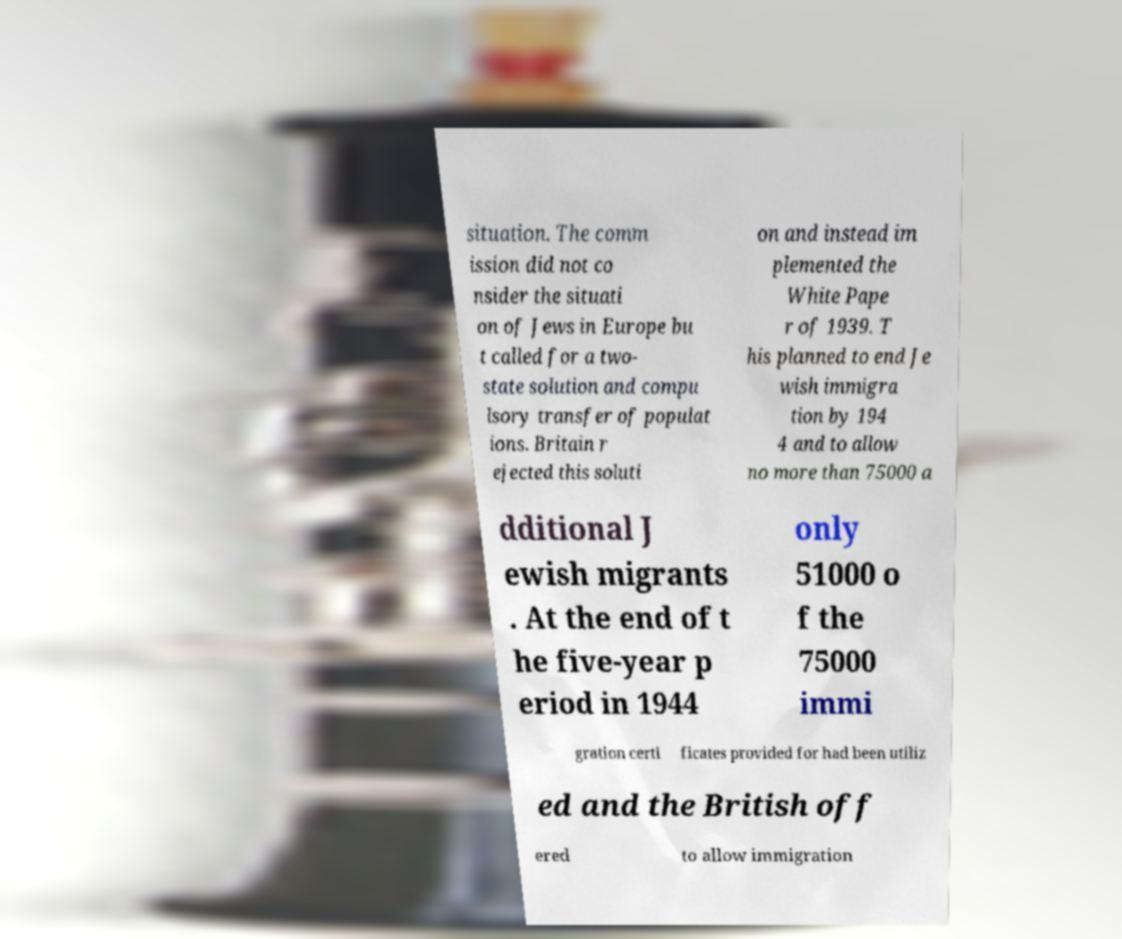I need the written content from this picture converted into text. Can you do that? situation. The comm ission did not co nsider the situati on of Jews in Europe bu t called for a two- state solution and compu lsory transfer of populat ions. Britain r ejected this soluti on and instead im plemented the White Pape r of 1939. T his planned to end Je wish immigra tion by 194 4 and to allow no more than 75000 a dditional J ewish migrants . At the end of t he five-year p eriod in 1944 only 51000 o f the 75000 immi gration certi ficates provided for had been utiliz ed and the British off ered to allow immigration 